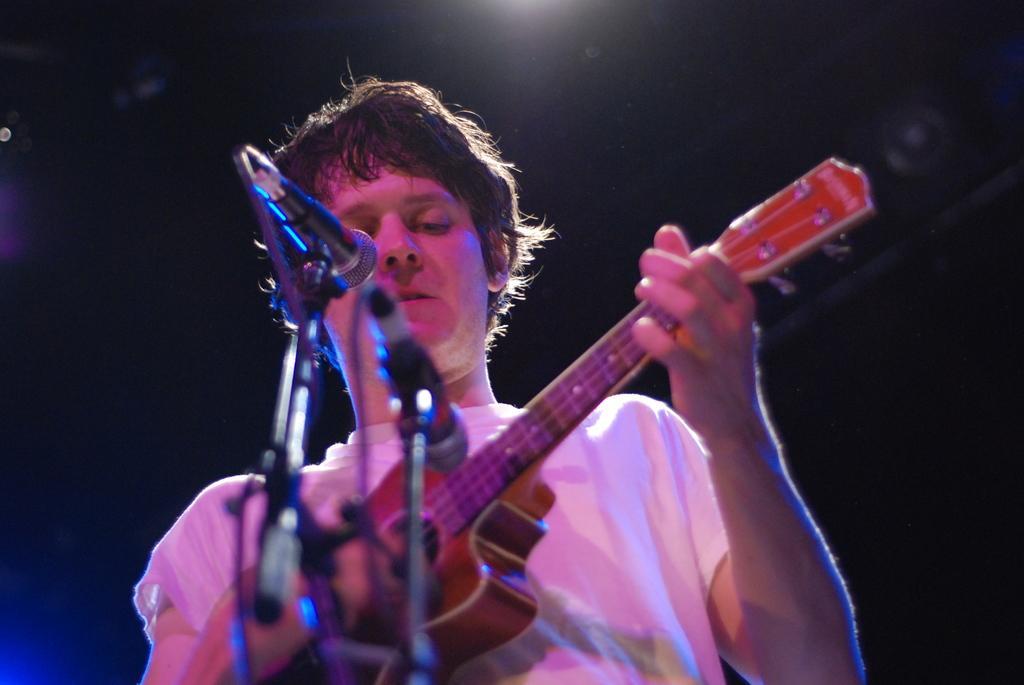Please provide a concise description of this image. In this image there is a person playing guitar in front of a mic. 